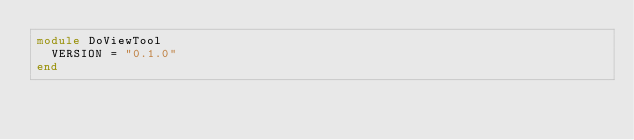Convert code to text. <code><loc_0><loc_0><loc_500><loc_500><_Ruby_>module DoViewTool
  VERSION = "0.1.0"
end
</code> 